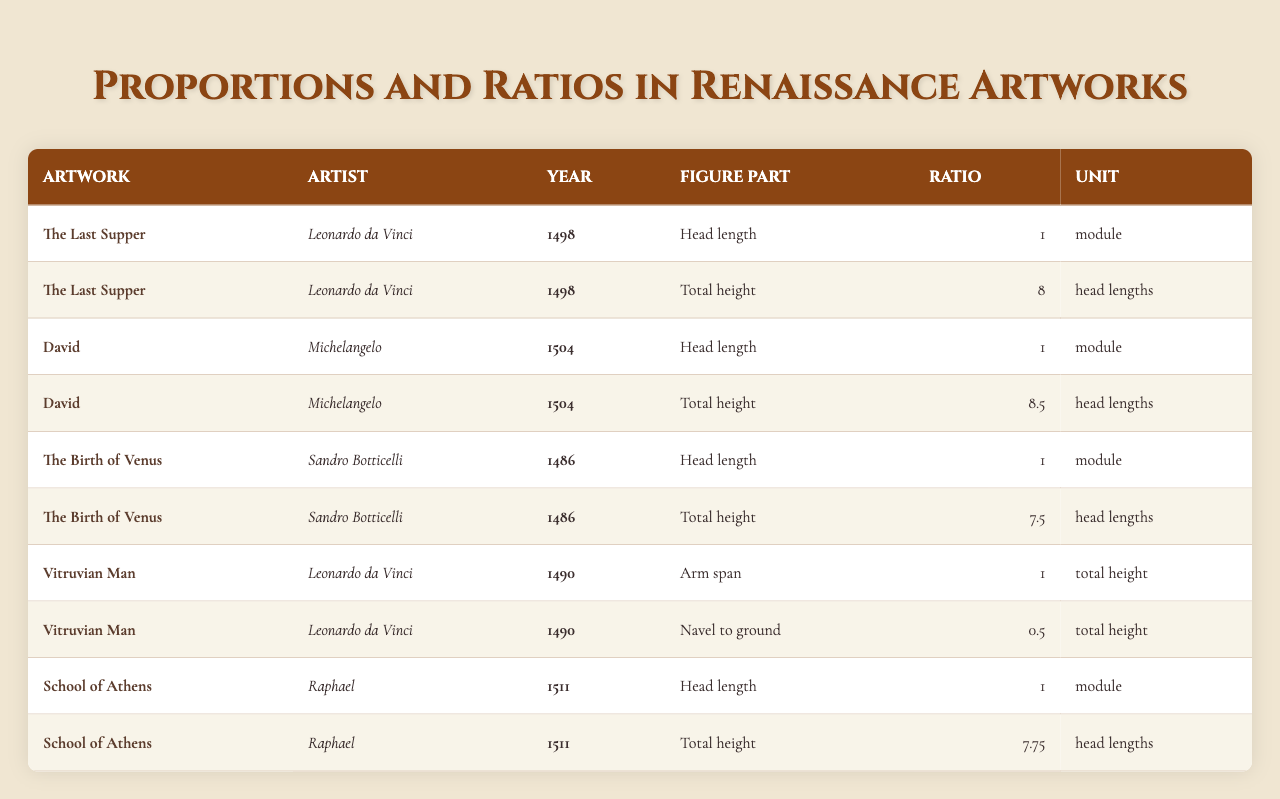What is the total height ratio of the figure in "David" by Michelangelo? According to the table, the total height ratio for Michelangelo's "David" is listed as 8.5 head lengths.
Answer: 8.5 head lengths Which artwork features a 7.75 head length ratio for total height? The artwork listed with a total height ratio of 7.75 head lengths is "School of Athens" by Raphael.
Answer: School of Athens Is the head length ratio for "Vitruvian Man" different from that of "The Last Supper"? In the table, both "Vitruvian Man" and "The Last Supper" have a head length ratio of 1 module, which means they are the same.
Answer: No What is the average total height ratio across all artworks listed in the table? To find the average, add the total height ratios: 8 (Last Supper) + 8.5 (David) + 7.5 (Birth of Venus) + 7.75 (School of Athens) = 32.75. There are 4 artworks, so the average is 32.75 / 4 = 8.1875.
Answer: 8.1875 Which artist has the highest total height ratio in their artwork? Michelangelo's "David" has the highest total height ratio at 8.5 head lengths, compared to the others.
Answer: Michelangelo For "The Birth of Venus," how does the total height compare to the other artworks? The total height for "The Birth of Venus" is 7.5 head lengths, which is lower than Michelangelo's 8.5 and Leonardo's 8, but higher than Raphael's 7.75.
Answer: Lower than Michelangelo's and Leonardo's, higher than Raphael's What is the ratio of the navel to the ground in "Vitruvian Man"? The table indicates that the ratio of navel to ground in "Vitruvian Man" is 0.5 of the total height.
Answer: 0.5 total height Is there any artwork that has a head length ratio of 1? Yes, both "The Last Supper" and "David" have a head length ratio of 1 module.
Answer: Yes Calculate the difference in total height ratios between "The Last Supper" and "School of Athens." "The Last Supper" has a total height ratio of 8 head lengths, while "School of Athens" has a ratio of 7.75 head lengths. The difference is 8 - 7.75 = 0.25 head lengths.
Answer: 0.25 head lengths What is the unit of measurement used for the head length ratios in the table? The unit of measurement for head length ratios in the table is "module."
Answer: Module 